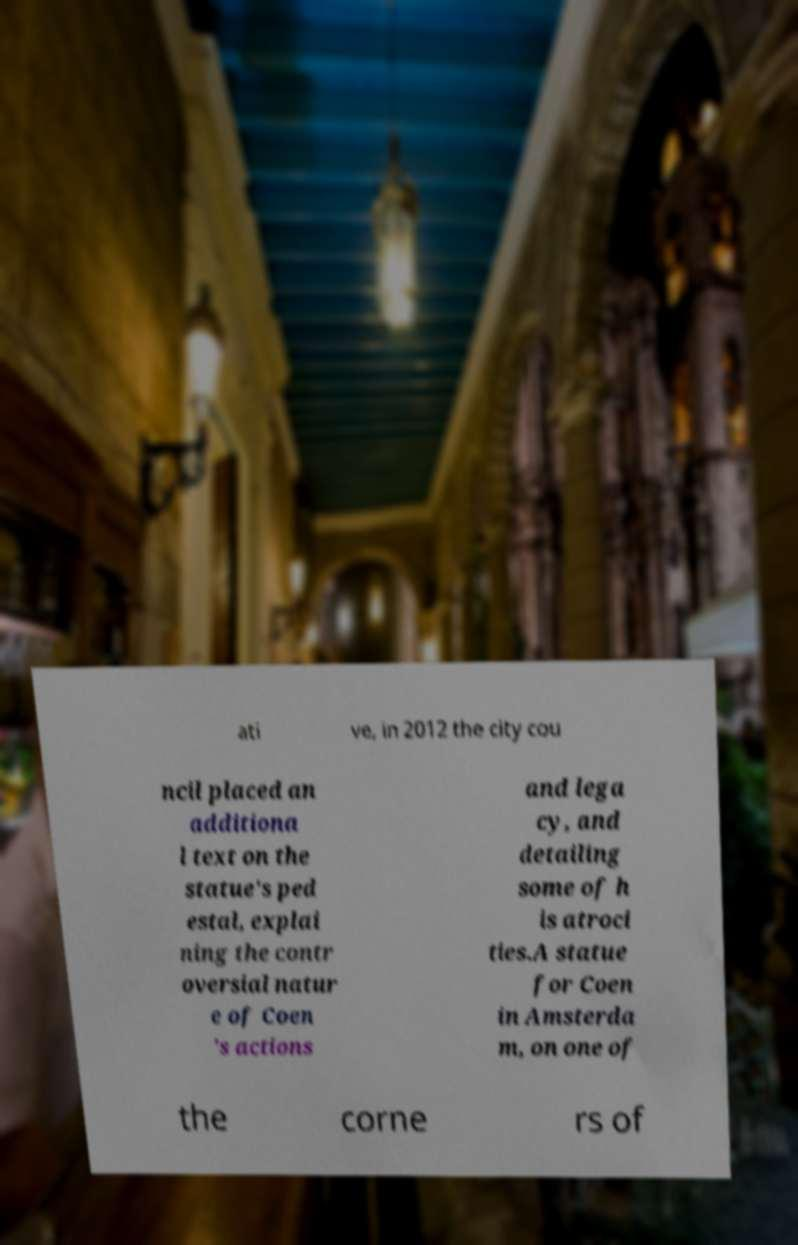Please read and relay the text visible in this image. What does it say? ati ve, in 2012 the city cou ncil placed an additiona l text on the statue's ped estal, explai ning the contr oversial natur e of Coen 's actions and lega cy, and detailing some of h is atroci ties.A statue for Coen in Amsterda m, on one of the corne rs of 